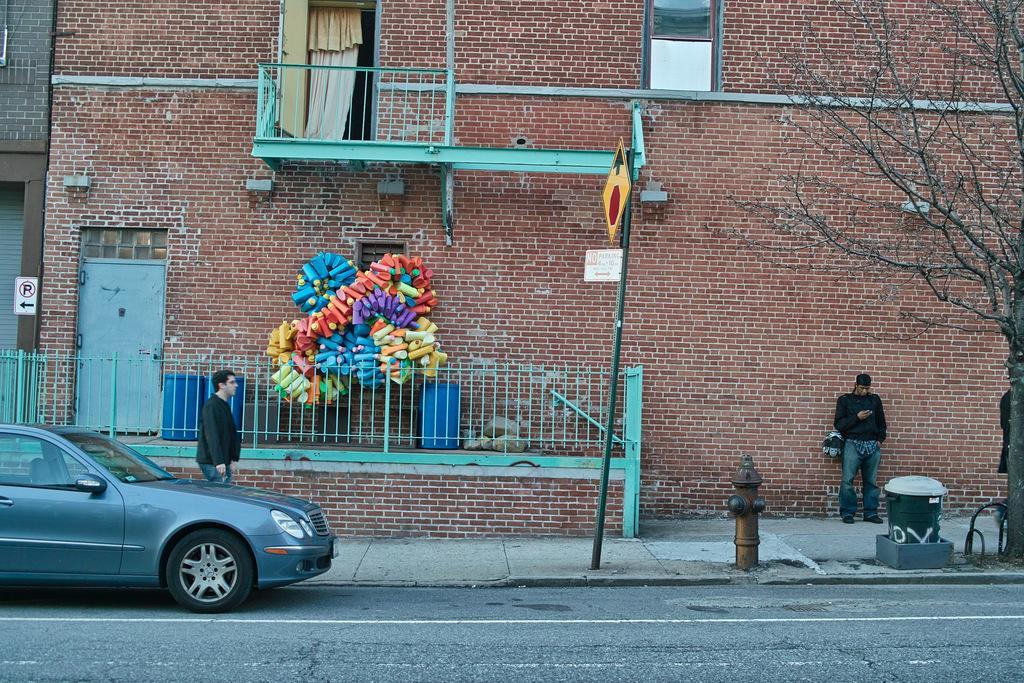Describe this image in one or two sentences. In this image I can see buildings, signboards, pole, curtain, doors, railings, people, hydrant, bin, tree, vehicle and objects.   